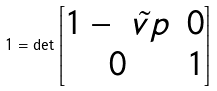<formula> <loc_0><loc_0><loc_500><loc_500>1 = \det \begin{bmatrix} 1 - \tilde { \ v p } & 0 \\ 0 & 1 \end{bmatrix}</formula> 